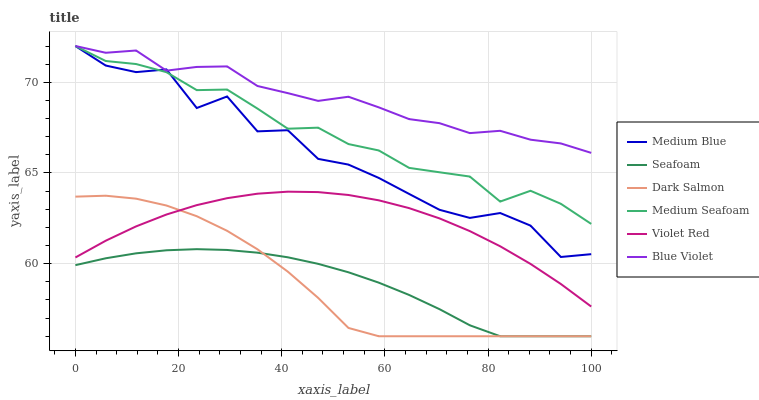Does Medium Blue have the minimum area under the curve?
Answer yes or no. No. Does Medium Blue have the maximum area under the curve?
Answer yes or no. No. Is Medium Blue the smoothest?
Answer yes or no. No. Is Seafoam the roughest?
Answer yes or no. No. Does Medium Blue have the lowest value?
Answer yes or no. No. Does Seafoam have the highest value?
Answer yes or no. No. Is Violet Red less than Medium Blue?
Answer yes or no. Yes. Is Blue Violet greater than Dark Salmon?
Answer yes or no. Yes. Does Violet Red intersect Medium Blue?
Answer yes or no. No. 